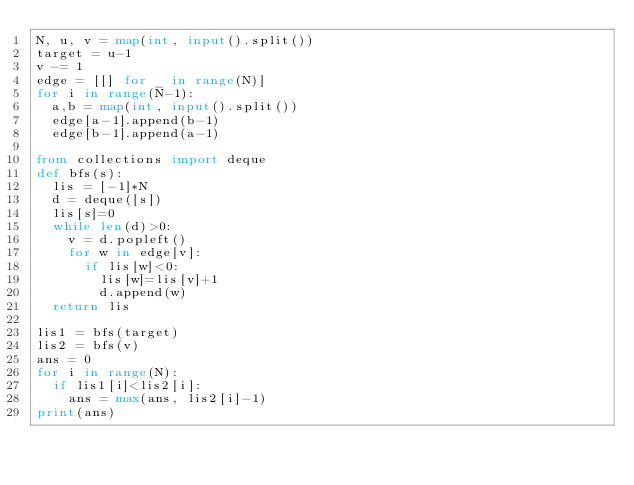<code> <loc_0><loc_0><loc_500><loc_500><_Python_>N, u, v = map(int, input().split())
target = u-1
v -= 1
edge = [[] for _ in range(N)]
for i in range(N-1):
  a,b = map(int, input().split())
  edge[a-1].append(b-1)
  edge[b-1].append(a-1)

from collections import deque
def bfs(s):
  lis = [-1]*N
  d = deque([s])
  lis[s]=0
  while len(d)>0:
    v = d.popleft()
    for w in edge[v]:
      if lis[w]<0:
        lis[w]=lis[v]+1
        d.append(w)
  return lis

lis1 = bfs(target)
lis2 = bfs(v)
ans = 0
for i in range(N):
  if lis1[i]<lis2[i]:
    ans = max(ans, lis2[i]-1)
print(ans)</code> 